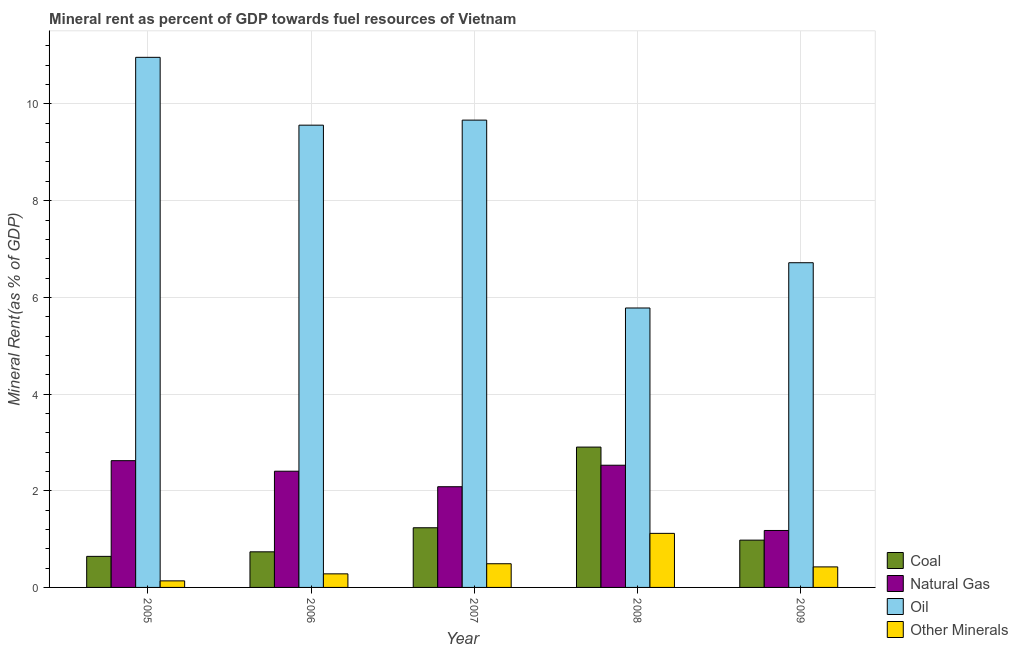Are the number of bars on each tick of the X-axis equal?
Make the answer very short. Yes. How many bars are there on the 4th tick from the right?
Ensure brevity in your answer.  4. What is the label of the 2nd group of bars from the left?
Make the answer very short. 2006. In how many cases, is the number of bars for a given year not equal to the number of legend labels?
Offer a terse response. 0. What is the natural gas rent in 2009?
Your response must be concise. 1.18. Across all years, what is the maximum coal rent?
Your answer should be compact. 2.9. Across all years, what is the minimum coal rent?
Ensure brevity in your answer.  0.64. In which year was the coal rent maximum?
Ensure brevity in your answer.  2008. What is the total natural gas rent in the graph?
Provide a succinct answer. 10.81. What is the difference between the  rent of other minerals in 2006 and that in 2009?
Your response must be concise. -0.14. What is the difference between the natural gas rent in 2005 and the  rent of other minerals in 2008?
Your response must be concise. 0.09. What is the average  rent of other minerals per year?
Your answer should be compact. 0.49. What is the ratio of the  rent of other minerals in 2006 to that in 2009?
Your answer should be very brief. 0.66. What is the difference between the highest and the second highest coal rent?
Ensure brevity in your answer.  1.67. What is the difference between the highest and the lowest coal rent?
Make the answer very short. 2.26. In how many years, is the natural gas rent greater than the average natural gas rent taken over all years?
Keep it short and to the point. 3. Is the sum of the oil rent in 2005 and 2009 greater than the maximum coal rent across all years?
Provide a short and direct response. Yes. What does the 4th bar from the left in 2009 represents?
Provide a short and direct response. Other Minerals. What does the 1st bar from the right in 2008 represents?
Offer a very short reply. Other Minerals. Are the values on the major ticks of Y-axis written in scientific E-notation?
Give a very brief answer. No. How many legend labels are there?
Offer a very short reply. 4. How are the legend labels stacked?
Make the answer very short. Vertical. What is the title of the graph?
Give a very brief answer. Mineral rent as percent of GDP towards fuel resources of Vietnam. What is the label or title of the X-axis?
Keep it short and to the point. Year. What is the label or title of the Y-axis?
Provide a succinct answer. Mineral Rent(as % of GDP). What is the Mineral Rent(as % of GDP) in Coal in 2005?
Provide a succinct answer. 0.64. What is the Mineral Rent(as % of GDP) in Natural Gas in 2005?
Make the answer very short. 2.62. What is the Mineral Rent(as % of GDP) of Oil in 2005?
Make the answer very short. 10.96. What is the Mineral Rent(as % of GDP) of Other Minerals in 2005?
Your answer should be very brief. 0.14. What is the Mineral Rent(as % of GDP) in Coal in 2006?
Your answer should be very brief. 0.74. What is the Mineral Rent(as % of GDP) in Natural Gas in 2006?
Your answer should be compact. 2.4. What is the Mineral Rent(as % of GDP) of Oil in 2006?
Your answer should be compact. 9.56. What is the Mineral Rent(as % of GDP) of Other Minerals in 2006?
Your answer should be compact. 0.28. What is the Mineral Rent(as % of GDP) in Coal in 2007?
Make the answer very short. 1.23. What is the Mineral Rent(as % of GDP) of Natural Gas in 2007?
Offer a very short reply. 2.08. What is the Mineral Rent(as % of GDP) in Oil in 2007?
Provide a short and direct response. 9.67. What is the Mineral Rent(as % of GDP) in Other Minerals in 2007?
Make the answer very short. 0.49. What is the Mineral Rent(as % of GDP) of Coal in 2008?
Your answer should be compact. 2.9. What is the Mineral Rent(as % of GDP) of Natural Gas in 2008?
Offer a very short reply. 2.53. What is the Mineral Rent(as % of GDP) in Oil in 2008?
Give a very brief answer. 5.78. What is the Mineral Rent(as % of GDP) of Other Minerals in 2008?
Offer a very short reply. 1.12. What is the Mineral Rent(as % of GDP) in Coal in 2009?
Keep it short and to the point. 0.98. What is the Mineral Rent(as % of GDP) in Natural Gas in 2009?
Offer a terse response. 1.18. What is the Mineral Rent(as % of GDP) in Oil in 2009?
Provide a short and direct response. 6.72. What is the Mineral Rent(as % of GDP) of Other Minerals in 2009?
Keep it short and to the point. 0.42. Across all years, what is the maximum Mineral Rent(as % of GDP) in Coal?
Give a very brief answer. 2.9. Across all years, what is the maximum Mineral Rent(as % of GDP) of Natural Gas?
Provide a short and direct response. 2.62. Across all years, what is the maximum Mineral Rent(as % of GDP) in Oil?
Make the answer very short. 10.96. Across all years, what is the maximum Mineral Rent(as % of GDP) in Other Minerals?
Your answer should be compact. 1.12. Across all years, what is the minimum Mineral Rent(as % of GDP) of Coal?
Provide a succinct answer. 0.64. Across all years, what is the minimum Mineral Rent(as % of GDP) of Natural Gas?
Offer a very short reply. 1.18. Across all years, what is the minimum Mineral Rent(as % of GDP) of Oil?
Your answer should be very brief. 5.78. Across all years, what is the minimum Mineral Rent(as % of GDP) in Other Minerals?
Give a very brief answer. 0.14. What is the total Mineral Rent(as % of GDP) of Coal in the graph?
Provide a succinct answer. 6.49. What is the total Mineral Rent(as % of GDP) in Natural Gas in the graph?
Your response must be concise. 10.81. What is the total Mineral Rent(as % of GDP) in Oil in the graph?
Provide a succinct answer. 42.69. What is the total Mineral Rent(as % of GDP) of Other Minerals in the graph?
Offer a very short reply. 2.45. What is the difference between the Mineral Rent(as % of GDP) of Coal in 2005 and that in 2006?
Your response must be concise. -0.09. What is the difference between the Mineral Rent(as % of GDP) of Natural Gas in 2005 and that in 2006?
Provide a short and direct response. 0.22. What is the difference between the Mineral Rent(as % of GDP) of Oil in 2005 and that in 2006?
Your answer should be compact. 1.4. What is the difference between the Mineral Rent(as % of GDP) of Other Minerals in 2005 and that in 2006?
Make the answer very short. -0.14. What is the difference between the Mineral Rent(as % of GDP) in Coal in 2005 and that in 2007?
Give a very brief answer. -0.59. What is the difference between the Mineral Rent(as % of GDP) of Natural Gas in 2005 and that in 2007?
Give a very brief answer. 0.54. What is the difference between the Mineral Rent(as % of GDP) in Oil in 2005 and that in 2007?
Ensure brevity in your answer.  1.3. What is the difference between the Mineral Rent(as % of GDP) in Other Minerals in 2005 and that in 2007?
Ensure brevity in your answer.  -0.35. What is the difference between the Mineral Rent(as % of GDP) in Coal in 2005 and that in 2008?
Give a very brief answer. -2.26. What is the difference between the Mineral Rent(as % of GDP) in Natural Gas in 2005 and that in 2008?
Your answer should be very brief. 0.09. What is the difference between the Mineral Rent(as % of GDP) in Oil in 2005 and that in 2008?
Your answer should be very brief. 5.18. What is the difference between the Mineral Rent(as % of GDP) of Other Minerals in 2005 and that in 2008?
Provide a short and direct response. -0.98. What is the difference between the Mineral Rent(as % of GDP) of Coal in 2005 and that in 2009?
Keep it short and to the point. -0.34. What is the difference between the Mineral Rent(as % of GDP) of Natural Gas in 2005 and that in 2009?
Keep it short and to the point. 1.44. What is the difference between the Mineral Rent(as % of GDP) of Oil in 2005 and that in 2009?
Your answer should be compact. 4.25. What is the difference between the Mineral Rent(as % of GDP) in Other Minerals in 2005 and that in 2009?
Your answer should be compact. -0.29. What is the difference between the Mineral Rent(as % of GDP) in Coal in 2006 and that in 2007?
Provide a short and direct response. -0.5. What is the difference between the Mineral Rent(as % of GDP) in Natural Gas in 2006 and that in 2007?
Provide a succinct answer. 0.32. What is the difference between the Mineral Rent(as % of GDP) in Oil in 2006 and that in 2007?
Keep it short and to the point. -0.1. What is the difference between the Mineral Rent(as % of GDP) of Other Minerals in 2006 and that in 2007?
Make the answer very short. -0.21. What is the difference between the Mineral Rent(as % of GDP) in Coal in 2006 and that in 2008?
Make the answer very short. -2.17. What is the difference between the Mineral Rent(as % of GDP) in Natural Gas in 2006 and that in 2008?
Offer a very short reply. -0.12. What is the difference between the Mineral Rent(as % of GDP) of Oil in 2006 and that in 2008?
Your answer should be very brief. 3.78. What is the difference between the Mineral Rent(as % of GDP) in Other Minerals in 2006 and that in 2008?
Your answer should be compact. -0.84. What is the difference between the Mineral Rent(as % of GDP) of Coal in 2006 and that in 2009?
Provide a succinct answer. -0.24. What is the difference between the Mineral Rent(as % of GDP) of Natural Gas in 2006 and that in 2009?
Make the answer very short. 1.23. What is the difference between the Mineral Rent(as % of GDP) in Oil in 2006 and that in 2009?
Offer a very short reply. 2.85. What is the difference between the Mineral Rent(as % of GDP) of Other Minerals in 2006 and that in 2009?
Keep it short and to the point. -0.14. What is the difference between the Mineral Rent(as % of GDP) of Coal in 2007 and that in 2008?
Your response must be concise. -1.67. What is the difference between the Mineral Rent(as % of GDP) of Natural Gas in 2007 and that in 2008?
Keep it short and to the point. -0.44. What is the difference between the Mineral Rent(as % of GDP) in Oil in 2007 and that in 2008?
Your answer should be compact. 3.89. What is the difference between the Mineral Rent(as % of GDP) in Other Minerals in 2007 and that in 2008?
Make the answer very short. -0.63. What is the difference between the Mineral Rent(as % of GDP) in Coal in 2007 and that in 2009?
Your response must be concise. 0.26. What is the difference between the Mineral Rent(as % of GDP) of Natural Gas in 2007 and that in 2009?
Your answer should be very brief. 0.91. What is the difference between the Mineral Rent(as % of GDP) in Oil in 2007 and that in 2009?
Ensure brevity in your answer.  2.95. What is the difference between the Mineral Rent(as % of GDP) of Other Minerals in 2007 and that in 2009?
Provide a succinct answer. 0.07. What is the difference between the Mineral Rent(as % of GDP) in Coal in 2008 and that in 2009?
Offer a very short reply. 1.92. What is the difference between the Mineral Rent(as % of GDP) of Natural Gas in 2008 and that in 2009?
Keep it short and to the point. 1.35. What is the difference between the Mineral Rent(as % of GDP) of Oil in 2008 and that in 2009?
Your answer should be very brief. -0.94. What is the difference between the Mineral Rent(as % of GDP) of Other Minerals in 2008 and that in 2009?
Provide a succinct answer. 0.69. What is the difference between the Mineral Rent(as % of GDP) in Coal in 2005 and the Mineral Rent(as % of GDP) in Natural Gas in 2006?
Your response must be concise. -1.76. What is the difference between the Mineral Rent(as % of GDP) in Coal in 2005 and the Mineral Rent(as % of GDP) in Oil in 2006?
Give a very brief answer. -8.92. What is the difference between the Mineral Rent(as % of GDP) of Coal in 2005 and the Mineral Rent(as % of GDP) of Other Minerals in 2006?
Your response must be concise. 0.36. What is the difference between the Mineral Rent(as % of GDP) in Natural Gas in 2005 and the Mineral Rent(as % of GDP) in Oil in 2006?
Ensure brevity in your answer.  -6.94. What is the difference between the Mineral Rent(as % of GDP) in Natural Gas in 2005 and the Mineral Rent(as % of GDP) in Other Minerals in 2006?
Ensure brevity in your answer.  2.34. What is the difference between the Mineral Rent(as % of GDP) of Oil in 2005 and the Mineral Rent(as % of GDP) of Other Minerals in 2006?
Provide a short and direct response. 10.68. What is the difference between the Mineral Rent(as % of GDP) of Coal in 2005 and the Mineral Rent(as % of GDP) of Natural Gas in 2007?
Provide a succinct answer. -1.44. What is the difference between the Mineral Rent(as % of GDP) in Coal in 2005 and the Mineral Rent(as % of GDP) in Oil in 2007?
Give a very brief answer. -9.02. What is the difference between the Mineral Rent(as % of GDP) of Coal in 2005 and the Mineral Rent(as % of GDP) of Other Minerals in 2007?
Give a very brief answer. 0.15. What is the difference between the Mineral Rent(as % of GDP) of Natural Gas in 2005 and the Mineral Rent(as % of GDP) of Oil in 2007?
Give a very brief answer. -7.04. What is the difference between the Mineral Rent(as % of GDP) in Natural Gas in 2005 and the Mineral Rent(as % of GDP) in Other Minerals in 2007?
Provide a short and direct response. 2.13. What is the difference between the Mineral Rent(as % of GDP) of Oil in 2005 and the Mineral Rent(as % of GDP) of Other Minerals in 2007?
Your response must be concise. 10.47. What is the difference between the Mineral Rent(as % of GDP) in Coal in 2005 and the Mineral Rent(as % of GDP) in Natural Gas in 2008?
Give a very brief answer. -1.89. What is the difference between the Mineral Rent(as % of GDP) of Coal in 2005 and the Mineral Rent(as % of GDP) of Oil in 2008?
Provide a short and direct response. -5.14. What is the difference between the Mineral Rent(as % of GDP) in Coal in 2005 and the Mineral Rent(as % of GDP) in Other Minerals in 2008?
Ensure brevity in your answer.  -0.48. What is the difference between the Mineral Rent(as % of GDP) of Natural Gas in 2005 and the Mineral Rent(as % of GDP) of Oil in 2008?
Make the answer very short. -3.16. What is the difference between the Mineral Rent(as % of GDP) of Natural Gas in 2005 and the Mineral Rent(as % of GDP) of Other Minerals in 2008?
Make the answer very short. 1.5. What is the difference between the Mineral Rent(as % of GDP) in Oil in 2005 and the Mineral Rent(as % of GDP) in Other Minerals in 2008?
Ensure brevity in your answer.  9.85. What is the difference between the Mineral Rent(as % of GDP) in Coal in 2005 and the Mineral Rent(as % of GDP) in Natural Gas in 2009?
Provide a succinct answer. -0.54. What is the difference between the Mineral Rent(as % of GDP) of Coal in 2005 and the Mineral Rent(as % of GDP) of Oil in 2009?
Your answer should be very brief. -6.07. What is the difference between the Mineral Rent(as % of GDP) of Coal in 2005 and the Mineral Rent(as % of GDP) of Other Minerals in 2009?
Offer a terse response. 0.22. What is the difference between the Mineral Rent(as % of GDP) of Natural Gas in 2005 and the Mineral Rent(as % of GDP) of Oil in 2009?
Provide a succinct answer. -4.09. What is the difference between the Mineral Rent(as % of GDP) in Natural Gas in 2005 and the Mineral Rent(as % of GDP) in Other Minerals in 2009?
Ensure brevity in your answer.  2.2. What is the difference between the Mineral Rent(as % of GDP) of Oil in 2005 and the Mineral Rent(as % of GDP) of Other Minerals in 2009?
Provide a succinct answer. 10.54. What is the difference between the Mineral Rent(as % of GDP) of Coal in 2006 and the Mineral Rent(as % of GDP) of Natural Gas in 2007?
Keep it short and to the point. -1.35. What is the difference between the Mineral Rent(as % of GDP) in Coal in 2006 and the Mineral Rent(as % of GDP) in Oil in 2007?
Keep it short and to the point. -8.93. What is the difference between the Mineral Rent(as % of GDP) of Coal in 2006 and the Mineral Rent(as % of GDP) of Other Minerals in 2007?
Offer a very short reply. 0.25. What is the difference between the Mineral Rent(as % of GDP) in Natural Gas in 2006 and the Mineral Rent(as % of GDP) in Oil in 2007?
Make the answer very short. -7.26. What is the difference between the Mineral Rent(as % of GDP) in Natural Gas in 2006 and the Mineral Rent(as % of GDP) in Other Minerals in 2007?
Provide a short and direct response. 1.91. What is the difference between the Mineral Rent(as % of GDP) in Oil in 2006 and the Mineral Rent(as % of GDP) in Other Minerals in 2007?
Your answer should be very brief. 9.07. What is the difference between the Mineral Rent(as % of GDP) of Coal in 2006 and the Mineral Rent(as % of GDP) of Natural Gas in 2008?
Offer a very short reply. -1.79. What is the difference between the Mineral Rent(as % of GDP) in Coal in 2006 and the Mineral Rent(as % of GDP) in Oil in 2008?
Your response must be concise. -5.04. What is the difference between the Mineral Rent(as % of GDP) in Coal in 2006 and the Mineral Rent(as % of GDP) in Other Minerals in 2008?
Your answer should be very brief. -0.38. What is the difference between the Mineral Rent(as % of GDP) of Natural Gas in 2006 and the Mineral Rent(as % of GDP) of Oil in 2008?
Provide a succinct answer. -3.38. What is the difference between the Mineral Rent(as % of GDP) in Natural Gas in 2006 and the Mineral Rent(as % of GDP) in Other Minerals in 2008?
Offer a terse response. 1.29. What is the difference between the Mineral Rent(as % of GDP) in Oil in 2006 and the Mineral Rent(as % of GDP) in Other Minerals in 2008?
Keep it short and to the point. 8.44. What is the difference between the Mineral Rent(as % of GDP) in Coal in 2006 and the Mineral Rent(as % of GDP) in Natural Gas in 2009?
Offer a very short reply. -0.44. What is the difference between the Mineral Rent(as % of GDP) of Coal in 2006 and the Mineral Rent(as % of GDP) of Oil in 2009?
Your answer should be compact. -5.98. What is the difference between the Mineral Rent(as % of GDP) in Coal in 2006 and the Mineral Rent(as % of GDP) in Other Minerals in 2009?
Your answer should be compact. 0.31. What is the difference between the Mineral Rent(as % of GDP) of Natural Gas in 2006 and the Mineral Rent(as % of GDP) of Oil in 2009?
Make the answer very short. -4.31. What is the difference between the Mineral Rent(as % of GDP) in Natural Gas in 2006 and the Mineral Rent(as % of GDP) in Other Minerals in 2009?
Your answer should be compact. 1.98. What is the difference between the Mineral Rent(as % of GDP) in Oil in 2006 and the Mineral Rent(as % of GDP) in Other Minerals in 2009?
Offer a very short reply. 9.14. What is the difference between the Mineral Rent(as % of GDP) of Coal in 2007 and the Mineral Rent(as % of GDP) of Natural Gas in 2008?
Provide a short and direct response. -1.29. What is the difference between the Mineral Rent(as % of GDP) of Coal in 2007 and the Mineral Rent(as % of GDP) of Oil in 2008?
Keep it short and to the point. -4.55. What is the difference between the Mineral Rent(as % of GDP) of Coal in 2007 and the Mineral Rent(as % of GDP) of Other Minerals in 2008?
Keep it short and to the point. 0.12. What is the difference between the Mineral Rent(as % of GDP) in Natural Gas in 2007 and the Mineral Rent(as % of GDP) in Oil in 2008?
Provide a short and direct response. -3.7. What is the difference between the Mineral Rent(as % of GDP) of Natural Gas in 2007 and the Mineral Rent(as % of GDP) of Other Minerals in 2008?
Your answer should be compact. 0.96. What is the difference between the Mineral Rent(as % of GDP) of Oil in 2007 and the Mineral Rent(as % of GDP) of Other Minerals in 2008?
Provide a short and direct response. 8.55. What is the difference between the Mineral Rent(as % of GDP) of Coal in 2007 and the Mineral Rent(as % of GDP) of Natural Gas in 2009?
Your answer should be very brief. 0.06. What is the difference between the Mineral Rent(as % of GDP) in Coal in 2007 and the Mineral Rent(as % of GDP) in Oil in 2009?
Your response must be concise. -5.48. What is the difference between the Mineral Rent(as % of GDP) of Coal in 2007 and the Mineral Rent(as % of GDP) of Other Minerals in 2009?
Your answer should be very brief. 0.81. What is the difference between the Mineral Rent(as % of GDP) in Natural Gas in 2007 and the Mineral Rent(as % of GDP) in Oil in 2009?
Your response must be concise. -4.63. What is the difference between the Mineral Rent(as % of GDP) in Natural Gas in 2007 and the Mineral Rent(as % of GDP) in Other Minerals in 2009?
Provide a short and direct response. 1.66. What is the difference between the Mineral Rent(as % of GDP) of Oil in 2007 and the Mineral Rent(as % of GDP) of Other Minerals in 2009?
Provide a succinct answer. 9.24. What is the difference between the Mineral Rent(as % of GDP) in Coal in 2008 and the Mineral Rent(as % of GDP) in Natural Gas in 2009?
Your answer should be very brief. 1.72. What is the difference between the Mineral Rent(as % of GDP) in Coal in 2008 and the Mineral Rent(as % of GDP) in Oil in 2009?
Make the answer very short. -3.81. What is the difference between the Mineral Rent(as % of GDP) in Coal in 2008 and the Mineral Rent(as % of GDP) in Other Minerals in 2009?
Your answer should be very brief. 2.48. What is the difference between the Mineral Rent(as % of GDP) in Natural Gas in 2008 and the Mineral Rent(as % of GDP) in Oil in 2009?
Make the answer very short. -4.19. What is the difference between the Mineral Rent(as % of GDP) in Natural Gas in 2008 and the Mineral Rent(as % of GDP) in Other Minerals in 2009?
Offer a terse response. 2.1. What is the difference between the Mineral Rent(as % of GDP) of Oil in 2008 and the Mineral Rent(as % of GDP) of Other Minerals in 2009?
Ensure brevity in your answer.  5.36. What is the average Mineral Rent(as % of GDP) in Coal per year?
Give a very brief answer. 1.3. What is the average Mineral Rent(as % of GDP) of Natural Gas per year?
Offer a terse response. 2.16. What is the average Mineral Rent(as % of GDP) of Oil per year?
Offer a terse response. 8.54. What is the average Mineral Rent(as % of GDP) in Other Minerals per year?
Give a very brief answer. 0.49. In the year 2005, what is the difference between the Mineral Rent(as % of GDP) of Coal and Mineral Rent(as % of GDP) of Natural Gas?
Offer a very short reply. -1.98. In the year 2005, what is the difference between the Mineral Rent(as % of GDP) in Coal and Mineral Rent(as % of GDP) in Oil?
Ensure brevity in your answer.  -10.32. In the year 2005, what is the difference between the Mineral Rent(as % of GDP) of Coal and Mineral Rent(as % of GDP) of Other Minerals?
Ensure brevity in your answer.  0.51. In the year 2005, what is the difference between the Mineral Rent(as % of GDP) in Natural Gas and Mineral Rent(as % of GDP) in Oil?
Provide a short and direct response. -8.34. In the year 2005, what is the difference between the Mineral Rent(as % of GDP) in Natural Gas and Mineral Rent(as % of GDP) in Other Minerals?
Make the answer very short. 2.49. In the year 2005, what is the difference between the Mineral Rent(as % of GDP) of Oil and Mineral Rent(as % of GDP) of Other Minerals?
Make the answer very short. 10.83. In the year 2006, what is the difference between the Mineral Rent(as % of GDP) of Coal and Mineral Rent(as % of GDP) of Natural Gas?
Give a very brief answer. -1.67. In the year 2006, what is the difference between the Mineral Rent(as % of GDP) in Coal and Mineral Rent(as % of GDP) in Oil?
Ensure brevity in your answer.  -8.83. In the year 2006, what is the difference between the Mineral Rent(as % of GDP) in Coal and Mineral Rent(as % of GDP) in Other Minerals?
Your answer should be compact. 0.46. In the year 2006, what is the difference between the Mineral Rent(as % of GDP) in Natural Gas and Mineral Rent(as % of GDP) in Oil?
Provide a succinct answer. -7.16. In the year 2006, what is the difference between the Mineral Rent(as % of GDP) in Natural Gas and Mineral Rent(as % of GDP) in Other Minerals?
Ensure brevity in your answer.  2.12. In the year 2006, what is the difference between the Mineral Rent(as % of GDP) of Oil and Mineral Rent(as % of GDP) of Other Minerals?
Your answer should be very brief. 9.28. In the year 2007, what is the difference between the Mineral Rent(as % of GDP) in Coal and Mineral Rent(as % of GDP) in Natural Gas?
Offer a very short reply. -0.85. In the year 2007, what is the difference between the Mineral Rent(as % of GDP) in Coal and Mineral Rent(as % of GDP) in Oil?
Offer a terse response. -8.43. In the year 2007, what is the difference between the Mineral Rent(as % of GDP) of Coal and Mineral Rent(as % of GDP) of Other Minerals?
Offer a very short reply. 0.74. In the year 2007, what is the difference between the Mineral Rent(as % of GDP) of Natural Gas and Mineral Rent(as % of GDP) of Oil?
Give a very brief answer. -7.58. In the year 2007, what is the difference between the Mineral Rent(as % of GDP) of Natural Gas and Mineral Rent(as % of GDP) of Other Minerals?
Your response must be concise. 1.59. In the year 2007, what is the difference between the Mineral Rent(as % of GDP) in Oil and Mineral Rent(as % of GDP) in Other Minerals?
Your response must be concise. 9.18. In the year 2008, what is the difference between the Mineral Rent(as % of GDP) of Coal and Mineral Rent(as % of GDP) of Natural Gas?
Keep it short and to the point. 0.38. In the year 2008, what is the difference between the Mineral Rent(as % of GDP) in Coal and Mineral Rent(as % of GDP) in Oil?
Provide a succinct answer. -2.88. In the year 2008, what is the difference between the Mineral Rent(as % of GDP) in Coal and Mineral Rent(as % of GDP) in Other Minerals?
Offer a terse response. 1.78. In the year 2008, what is the difference between the Mineral Rent(as % of GDP) of Natural Gas and Mineral Rent(as % of GDP) of Oil?
Give a very brief answer. -3.25. In the year 2008, what is the difference between the Mineral Rent(as % of GDP) in Natural Gas and Mineral Rent(as % of GDP) in Other Minerals?
Your response must be concise. 1.41. In the year 2008, what is the difference between the Mineral Rent(as % of GDP) in Oil and Mineral Rent(as % of GDP) in Other Minerals?
Make the answer very short. 4.66. In the year 2009, what is the difference between the Mineral Rent(as % of GDP) of Coal and Mineral Rent(as % of GDP) of Natural Gas?
Offer a very short reply. -0.2. In the year 2009, what is the difference between the Mineral Rent(as % of GDP) of Coal and Mineral Rent(as % of GDP) of Oil?
Provide a succinct answer. -5.74. In the year 2009, what is the difference between the Mineral Rent(as % of GDP) of Coal and Mineral Rent(as % of GDP) of Other Minerals?
Ensure brevity in your answer.  0.55. In the year 2009, what is the difference between the Mineral Rent(as % of GDP) of Natural Gas and Mineral Rent(as % of GDP) of Oil?
Keep it short and to the point. -5.54. In the year 2009, what is the difference between the Mineral Rent(as % of GDP) in Natural Gas and Mineral Rent(as % of GDP) in Other Minerals?
Provide a short and direct response. 0.75. In the year 2009, what is the difference between the Mineral Rent(as % of GDP) in Oil and Mineral Rent(as % of GDP) in Other Minerals?
Provide a short and direct response. 6.29. What is the ratio of the Mineral Rent(as % of GDP) of Coal in 2005 to that in 2006?
Keep it short and to the point. 0.87. What is the ratio of the Mineral Rent(as % of GDP) in Natural Gas in 2005 to that in 2006?
Your response must be concise. 1.09. What is the ratio of the Mineral Rent(as % of GDP) of Oil in 2005 to that in 2006?
Provide a short and direct response. 1.15. What is the ratio of the Mineral Rent(as % of GDP) of Other Minerals in 2005 to that in 2006?
Offer a very short reply. 0.48. What is the ratio of the Mineral Rent(as % of GDP) of Coal in 2005 to that in 2007?
Offer a terse response. 0.52. What is the ratio of the Mineral Rent(as % of GDP) in Natural Gas in 2005 to that in 2007?
Provide a succinct answer. 1.26. What is the ratio of the Mineral Rent(as % of GDP) of Oil in 2005 to that in 2007?
Your answer should be compact. 1.13. What is the ratio of the Mineral Rent(as % of GDP) in Other Minerals in 2005 to that in 2007?
Provide a short and direct response. 0.28. What is the ratio of the Mineral Rent(as % of GDP) in Coal in 2005 to that in 2008?
Keep it short and to the point. 0.22. What is the ratio of the Mineral Rent(as % of GDP) of Natural Gas in 2005 to that in 2008?
Provide a succinct answer. 1.04. What is the ratio of the Mineral Rent(as % of GDP) in Oil in 2005 to that in 2008?
Keep it short and to the point. 1.9. What is the ratio of the Mineral Rent(as % of GDP) in Other Minerals in 2005 to that in 2008?
Offer a terse response. 0.12. What is the ratio of the Mineral Rent(as % of GDP) in Coal in 2005 to that in 2009?
Provide a short and direct response. 0.66. What is the ratio of the Mineral Rent(as % of GDP) of Natural Gas in 2005 to that in 2009?
Keep it short and to the point. 2.23. What is the ratio of the Mineral Rent(as % of GDP) of Oil in 2005 to that in 2009?
Your answer should be very brief. 1.63. What is the ratio of the Mineral Rent(as % of GDP) in Other Minerals in 2005 to that in 2009?
Your answer should be compact. 0.32. What is the ratio of the Mineral Rent(as % of GDP) of Coal in 2006 to that in 2007?
Make the answer very short. 0.6. What is the ratio of the Mineral Rent(as % of GDP) in Natural Gas in 2006 to that in 2007?
Your answer should be compact. 1.15. What is the ratio of the Mineral Rent(as % of GDP) in Other Minerals in 2006 to that in 2007?
Offer a terse response. 0.57. What is the ratio of the Mineral Rent(as % of GDP) in Coal in 2006 to that in 2008?
Offer a very short reply. 0.25. What is the ratio of the Mineral Rent(as % of GDP) in Natural Gas in 2006 to that in 2008?
Offer a very short reply. 0.95. What is the ratio of the Mineral Rent(as % of GDP) in Oil in 2006 to that in 2008?
Your response must be concise. 1.65. What is the ratio of the Mineral Rent(as % of GDP) of Other Minerals in 2006 to that in 2008?
Offer a very short reply. 0.25. What is the ratio of the Mineral Rent(as % of GDP) of Coal in 2006 to that in 2009?
Keep it short and to the point. 0.75. What is the ratio of the Mineral Rent(as % of GDP) of Natural Gas in 2006 to that in 2009?
Offer a very short reply. 2.04. What is the ratio of the Mineral Rent(as % of GDP) in Oil in 2006 to that in 2009?
Ensure brevity in your answer.  1.42. What is the ratio of the Mineral Rent(as % of GDP) of Other Minerals in 2006 to that in 2009?
Ensure brevity in your answer.  0.66. What is the ratio of the Mineral Rent(as % of GDP) in Coal in 2007 to that in 2008?
Your response must be concise. 0.43. What is the ratio of the Mineral Rent(as % of GDP) of Natural Gas in 2007 to that in 2008?
Keep it short and to the point. 0.82. What is the ratio of the Mineral Rent(as % of GDP) of Oil in 2007 to that in 2008?
Provide a succinct answer. 1.67. What is the ratio of the Mineral Rent(as % of GDP) in Other Minerals in 2007 to that in 2008?
Offer a very short reply. 0.44. What is the ratio of the Mineral Rent(as % of GDP) in Coal in 2007 to that in 2009?
Give a very brief answer. 1.26. What is the ratio of the Mineral Rent(as % of GDP) in Natural Gas in 2007 to that in 2009?
Provide a succinct answer. 1.77. What is the ratio of the Mineral Rent(as % of GDP) in Oil in 2007 to that in 2009?
Your answer should be very brief. 1.44. What is the ratio of the Mineral Rent(as % of GDP) of Other Minerals in 2007 to that in 2009?
Offer a very short reply. 1.15. What is the ratio of the Mineral Rent(as % of GDP) of Coal in 2008 to that in 2009?
Offer a very short reply. 2.97. What is the ratio of the Mineral Rent(as % of GDP) of Natural Gas in 2008 to that in 2009?
Your answer should be very brief. 2.15. What is the ratio of the Mineral Rent(as % of GDP) of Oil in 2008 to that in 2009?
Offer a terse response. 0.86. What is the ratio of the Mineral Rent(as % of GDP) of Other Minerals in 2008 to that in 2009?
Offer a terse response. 2.63. What is the difference between the highest and the second highest Mineral Rent(as % of GDP) of Coal?
Offer a very short reply. 1.67. What is the difference between the highest and the second highest Mineral Rent(as % of GDP) of Natural Gas?
Provide a succinct answer. 0.09. What is the difference between the highest and the second highest Mineral Rent(as % of GDP) of Oil?
Ensure brevity in your answer.  1.3. What is the difference between the highest and the second highest Mineral Rent(as % of GDP) in Other Minerals?
Your answer should be very brief. 0.63. What is the difference between the highest and the lowest Mineral Rent(as % of GDP) of Coal?
Your answer should be very brief. 2.26. What is the difference between the highest and the lowest Mineral Rent(as % of GDP) of Natural Gas?
Offer a very short reply. 1.44. What is the difference between the highest and the lowest Mineral Rent(as % of GDP) of Oil?
Offer a terse response. 5.18. What is the difference between the highest and the lowest Mineral Rent(as % of GDP) in Other Minerals?
Make the answer very short. 0.98. 